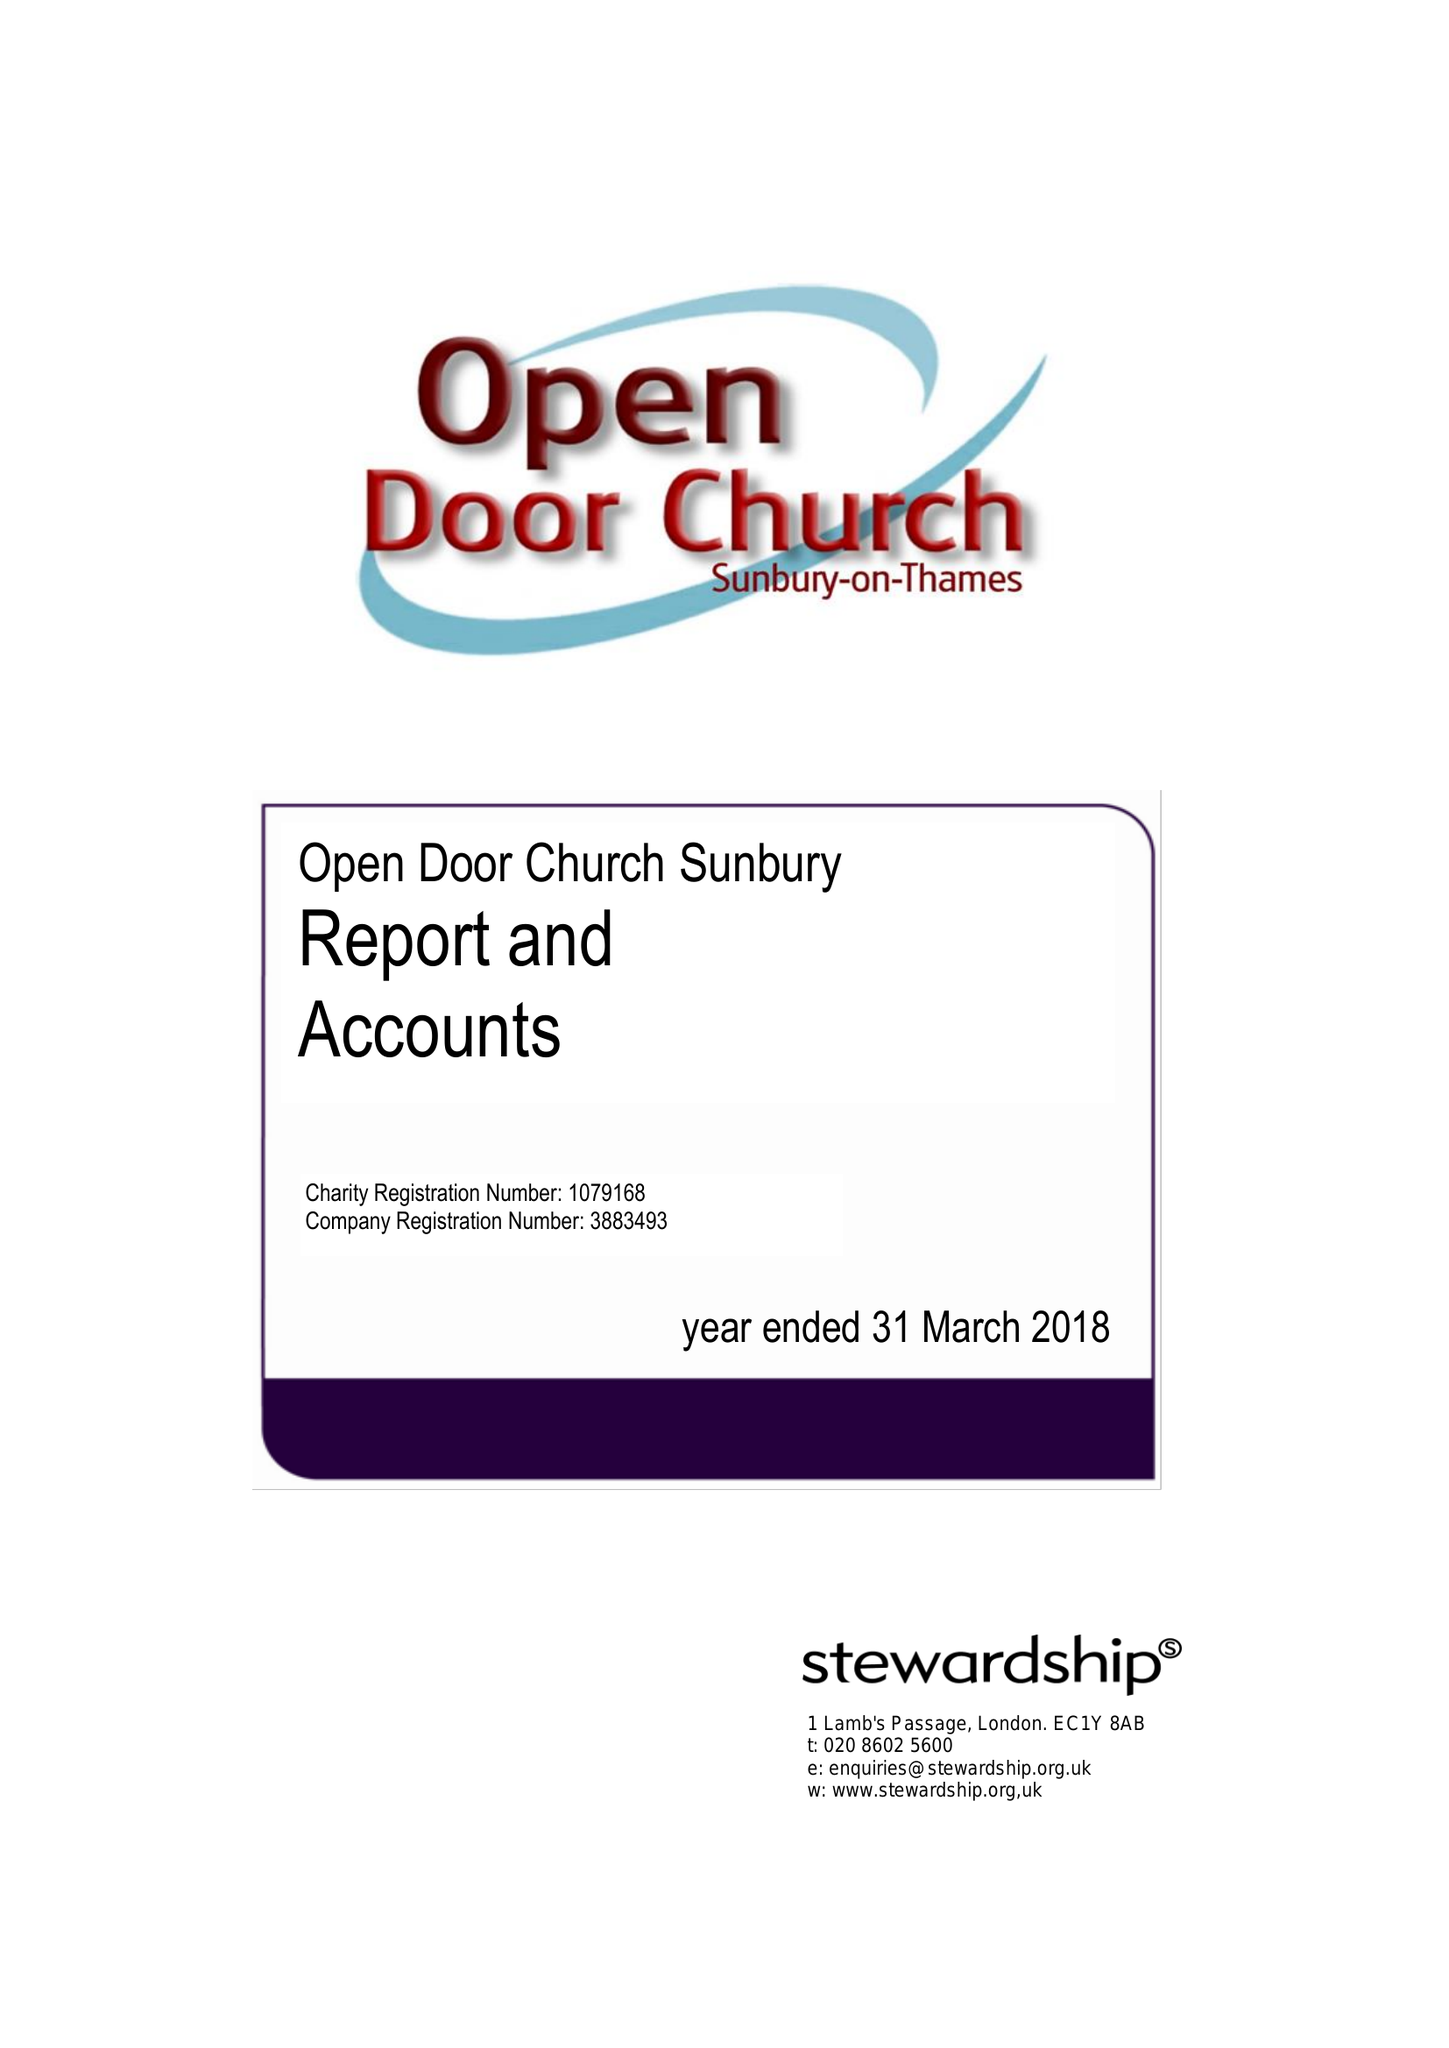What is the value for the charity_number?
Answer the question using a single word or phrase. 1079168 